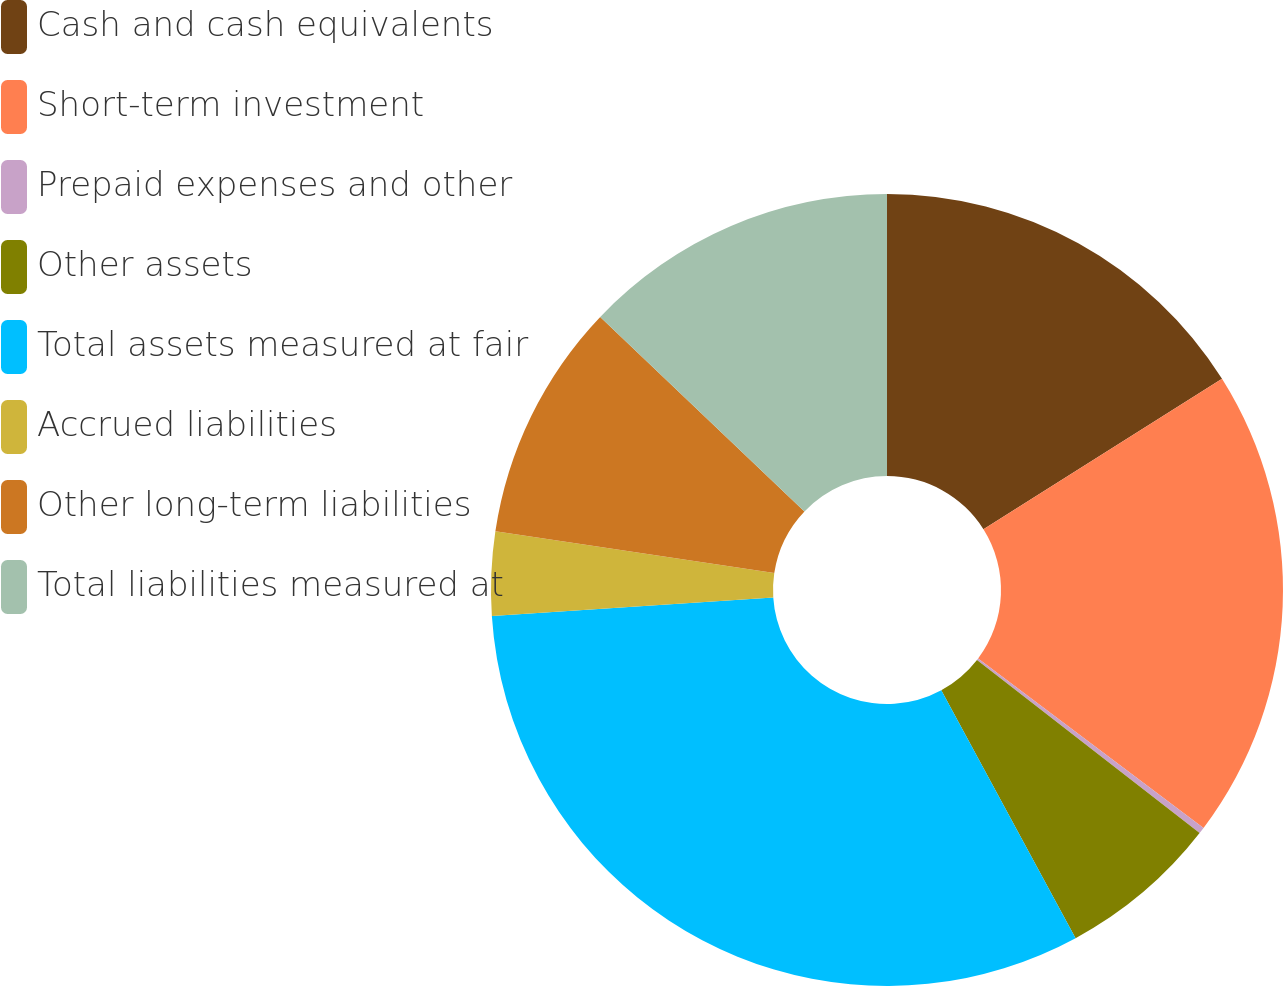<chart> <loc_0><loc_0><loc_500><loc_500><pie_chart><fcel>Cash and cash equivalents<fcel>Short-term investment<fcel>Prepaid expenses and other<fcel>Other assets<fcel>Total assets measured at fair<fcel>Accrued liabilities<fcel>Other long-term liabilities<fcel>Total liabilities measured at<nl><fcel>16.05%<fcel>19.21%<fcel>0.26%<fcel>6.58%<fcel>31.85%<fcel>3.42%<fcel>9.74%<fcel>12.89%<nl></chart> 